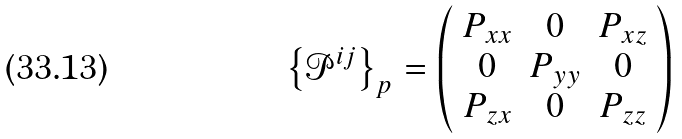Convert formula to latex. <formula><loc_0><loc_0><loc_500><loc_500>\left \{ \mathcal { P } ^ { i j } \right \} _ { p } = \left ( \begin{array} { c c c } P _ { x x } & 0 & P _ { x z } \\ 0 & P _ { y y } & 0 \\ P _ { z x } & 0 & P _ { z z } \end{array} \right )</formula> 